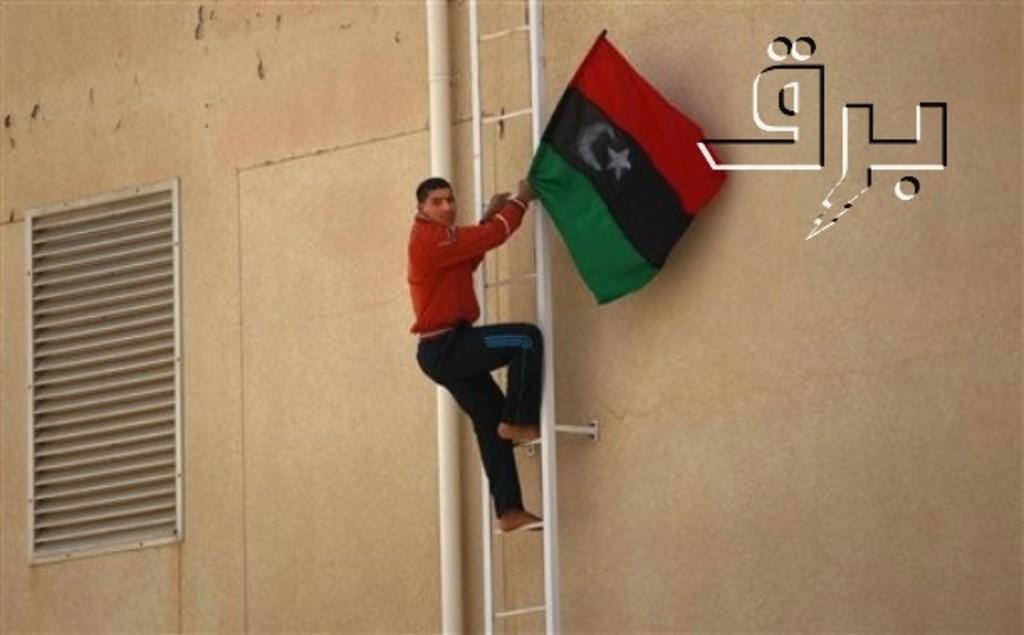In one or two sentences, can you explain what this image depicts? In this picture there is a man who is wearing a red jacket, trouser and holding a flag. He is standing on the ladder, beside that there is a pipe. On the left there is a exhaust duct. In the top right corner there is a watermark. 